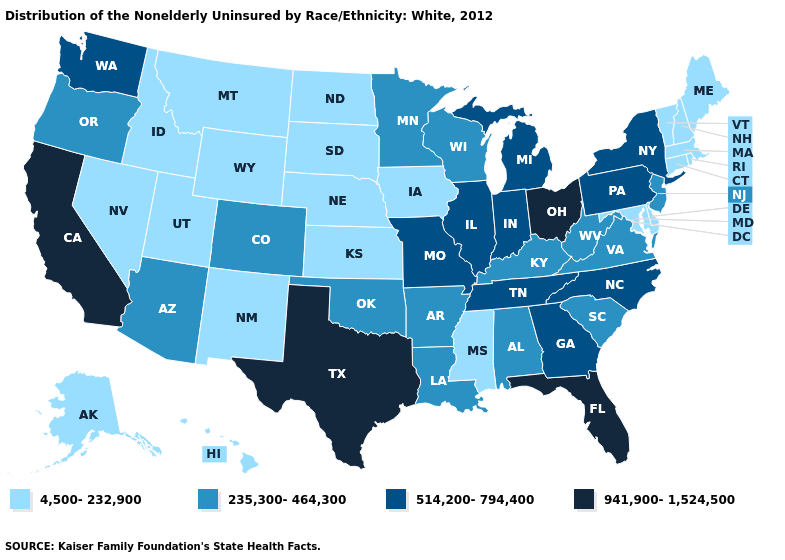Which states hav the highest value in the South?
Answer briefly. Florida, Texas. What is the lowest value in the South?
Keep it brief. 4,500-232,900. Does Nebraska have the lowest value in the MidWest?
Concise answer only. Yes. Does Georgia have the lowest value in the South?
Concise answer only. No. Name the states that have a value in the range 235,300-464,300?
Be succinct. Alabama, Arizona, Arkansas, Colorado, Kentucky, Louisiana, Minnesota, New Jersey, Oklahoma, Oregon, South Carolina, Virginia, West Virginia, Wisconsin. Among the states that border Louisiana , which have the highest value?
Concise answer only. Texas. What is the highest value in states that border Illinois?
Quick response, please. 514,200-794,400. What is the highest value in states that border Arkansas?
Give a very brief answer. 941,900-1,524,500. Which states have the highest value in the USA?
Be succinct. California, Florida, Ohio, Texas. What is the value of New Jersey?
Quick response, please. 235,300-464,300. What is the value of West Virginia?
Answer briefly. 235,300-464,300. What is the value of Illinois?
Quick response, please. 514,200-794,400. What is the value of Pennsylvania?
Short answer required. 514,200-794,400. Name the states that have a value in the range 514,200-794,400?
Concise answer only. Georgia, Illinois, Indiana, Michigan, Missouri, New York, North Carolina, Pennsylvania, Tennessee, Washington. Name the states that have a value in the range 4,500-232,900?
Concise answer only. Alaska, Connecticut, Delaware, Hawaii, Idaho, Iowa, Kansas, Maine, Maryland, Massachusetts, Mississippi, Montana, Nebraska, Nevada, New Hampshire, New Mexico, North Dakota, Rhode Island, South Dakota, Utah, Vermont, Wyoming. 